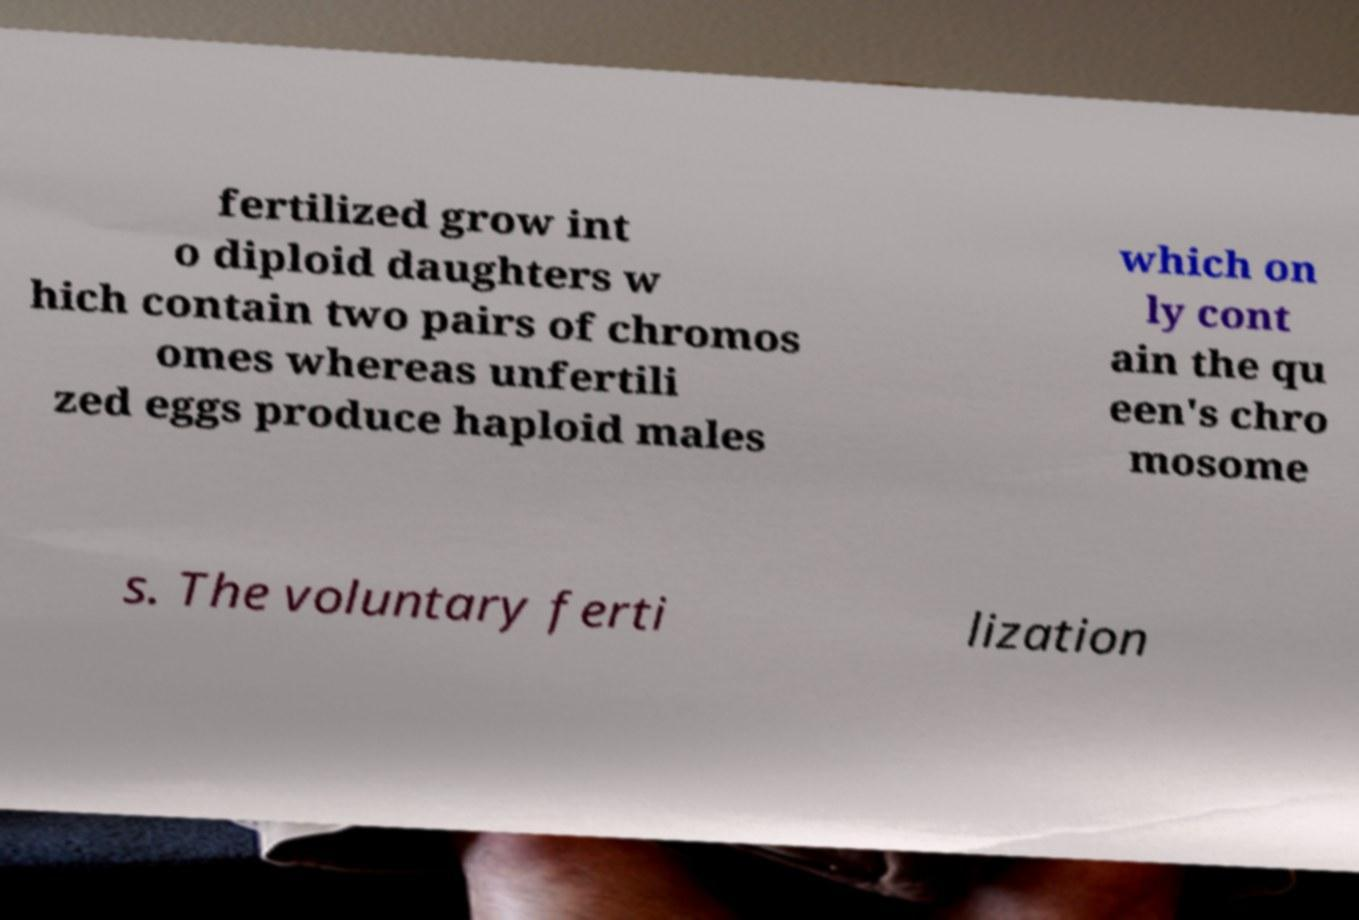Could you extract and type out the text from this image? fertilized grow int o diploid daughters w hich contain two pairs of chromos omes whereas unfertili zed eggs produce haploid males which on ly cont ain the qu een's chro mosome s. The voluntary ferti lization 